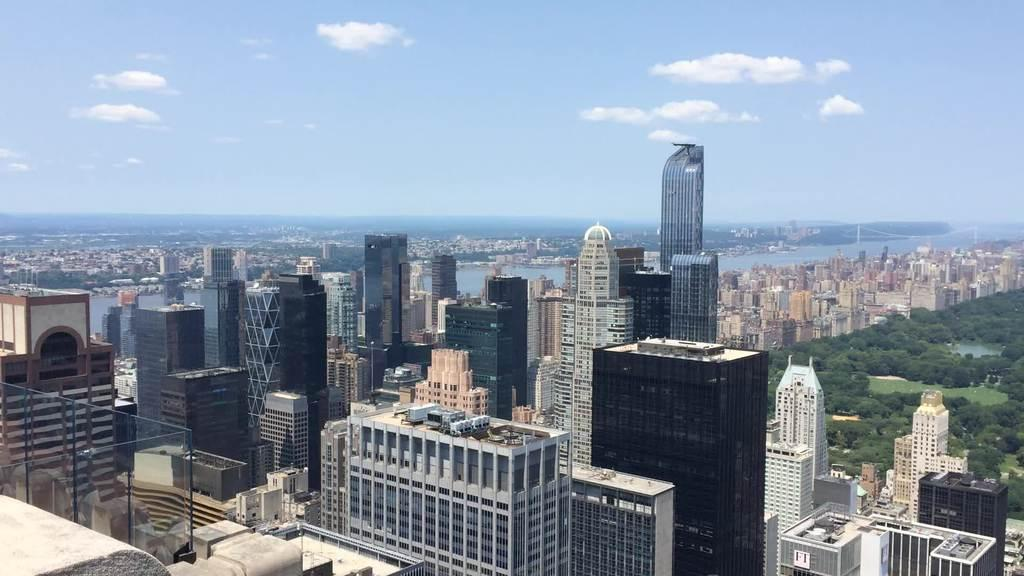What type of structures can be seen in the image? There are buildings in the image. What feature do the buildings have? The buildings have glass windows. What architectural element is present in the image? There is a bridge in the image. What natural element is visible in the image? There is water visible in the image. What type of vegetation can be seen in the image? There are trees in the image. How would you describe the color of the sky in the image? The sky is a combination of white and blue colors. How many worms can be seen crawling on the bridge in the image? There are no worms present in the image; the focus is on the buildings, bridge, water, trees, and sky. 